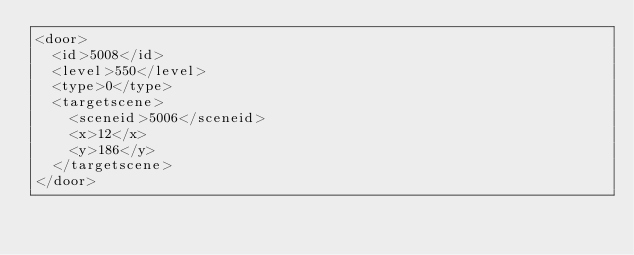<code> <loc_0><loc_0><loc_500><loc_500><_XML_><door>
  <id>5008</id>
  <level>550</level>
  <type>0</type>
  <targetscene>
    <sceneid>5006</sceneid>
    <x>12</x>
    <y>186</y>
  </targetscene>
</door></code> 